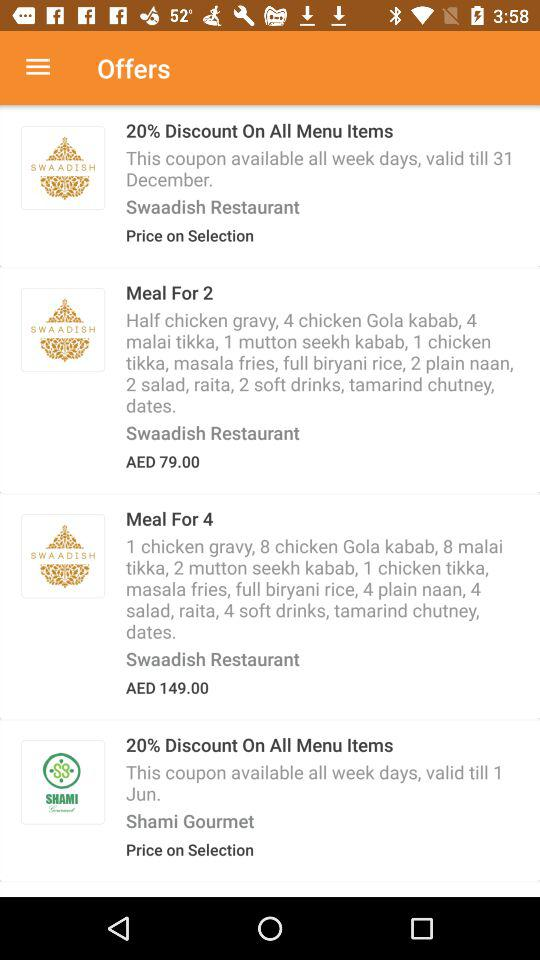How many more Swaadish offers are there than Shami Gourmet offers?
Answer the question using a single word or phrase. 2 